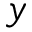Convert formula to latex. <formula><loc_0><loc_0><loc_500><loc_500>y</formula> 